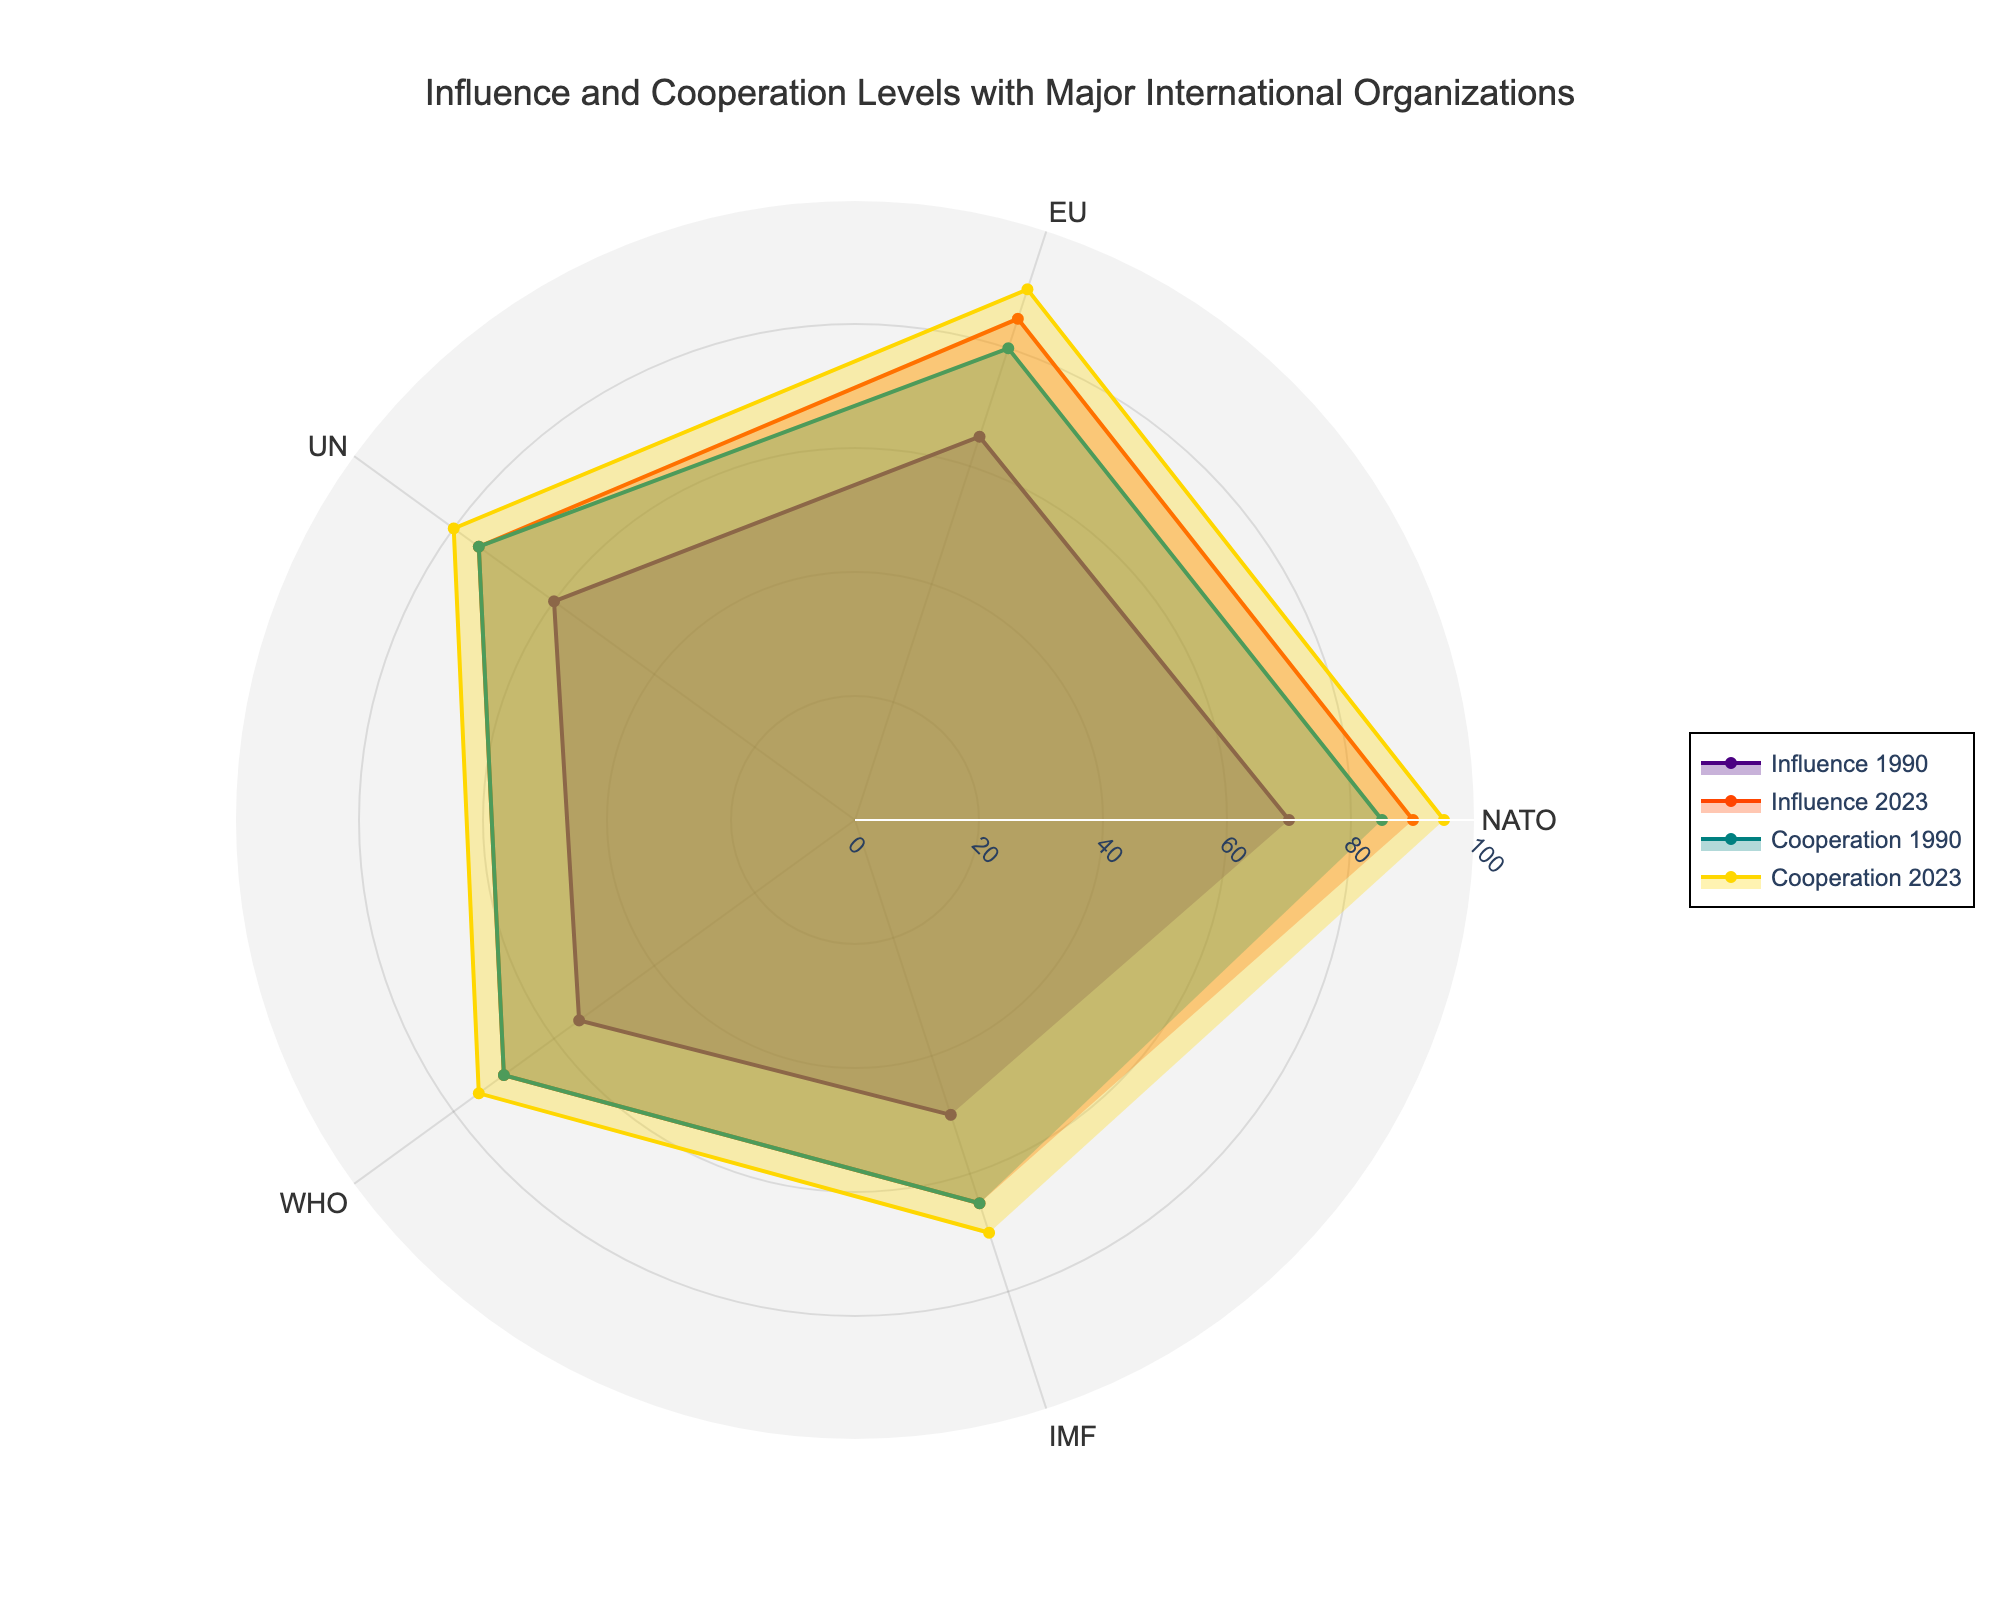What's the title of the chart? The title is usually prominently displayed at the top of the chart. This one reads "Influence and Cooperation Levels with Major International Organizations".
Answer: Influence and Cooperation Levels with Major International Organizations Which organization had the lowest influence level in 1990? By examining the radar chart, the organization with the lowest value on the "Influence 1990" plot is observed. For "Influence 1990", IMF shows the lowest level at 50.
Answer: IMF What’s the difference in cooperation levels with WHO between 1990 and 2023? First, find the cooperation levels for WHO in 1990 and 2023, which are 70 and 75 respectively. Subtracting these gives: 75 - 70 = 5.
Answer: 5 Which year showed higher influence levels for NATO? Look at the influence levels of NATO for both 1990 and 2023. In 1990, it is 70, and in 2023, it is 90. Clearly, 2023 shows a higher influence level.
Answer: 2023 How has the influence level with the EU changed from 1990 to 2023? Compare the influence levels of the EU from 1990 (65) to 2023 (85) by subtracting the former from the latter: 85 - 65 = 20.
Answer: Increased by 20 Which organization had the smallest change in cooperation levels from 1990 to 2023? Calculate the changes in cooperation levels for all organizations: NATO (95-85=10), EU (90-80=10), UN (80-75=5), WHO (75-70=5), and IMF (70-65=5). The smallest change, which is 5, occurs with UN, WHO, and IMF.
Answer: UN, WHO, IMF In 2023, which organization had the highest level of cooperation? Look at the "Cooperation 2023" data on the chart. NATO has the highest cooperation level at 95.
Answer: NATO Which organization saw the greatest increase in influence levels from 1990 to 2023? Calculate the increases in influence levels: NATO (90-70=20), EU (85-65=20), UN (75-60=15), WHO (70-55=15), IMF (65-50=15). NATO and EU both saw the greatest increase of 20.
Answer: NATO, EU What's the average cooperation level across all organizations in 2023? Sum the cooperation levels in 2023: 95 (NATO) + 90 (EU) + 80 (UN) + 75 (WHO) + 70 (IMF) = 410. Divide by the number of organizations (5): 410/5 = 82.
Answer: 82 